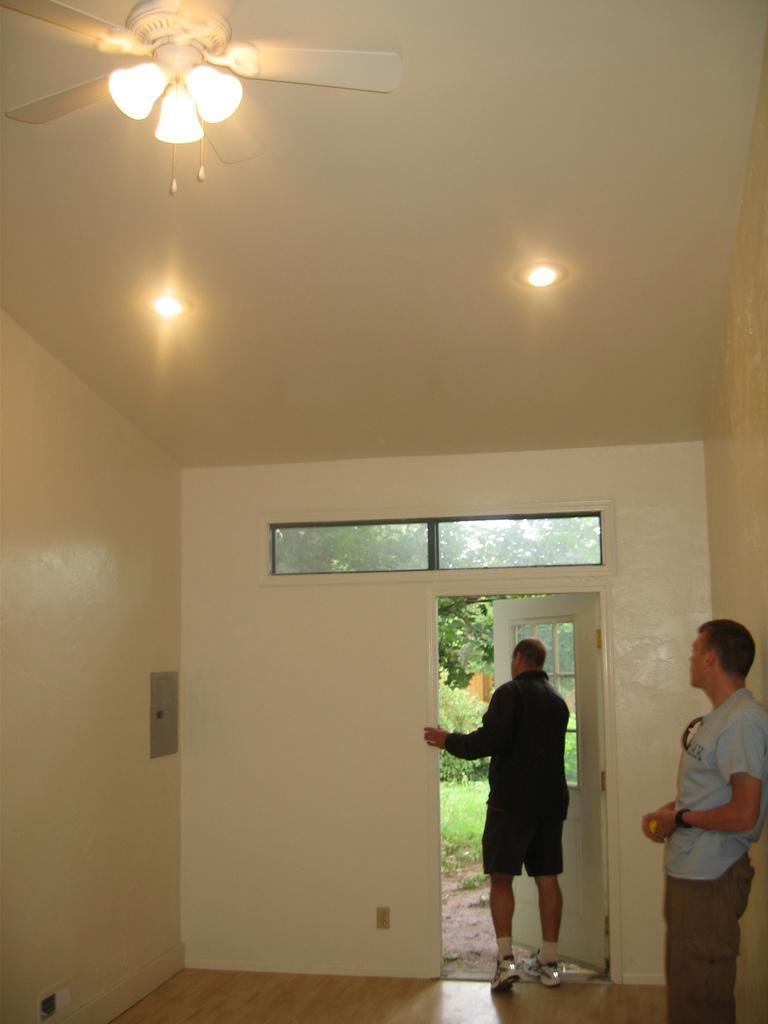Please provide a concise description of this image. In this image we can see two people and there is a door. At the top there are lights and we can see a fan. 